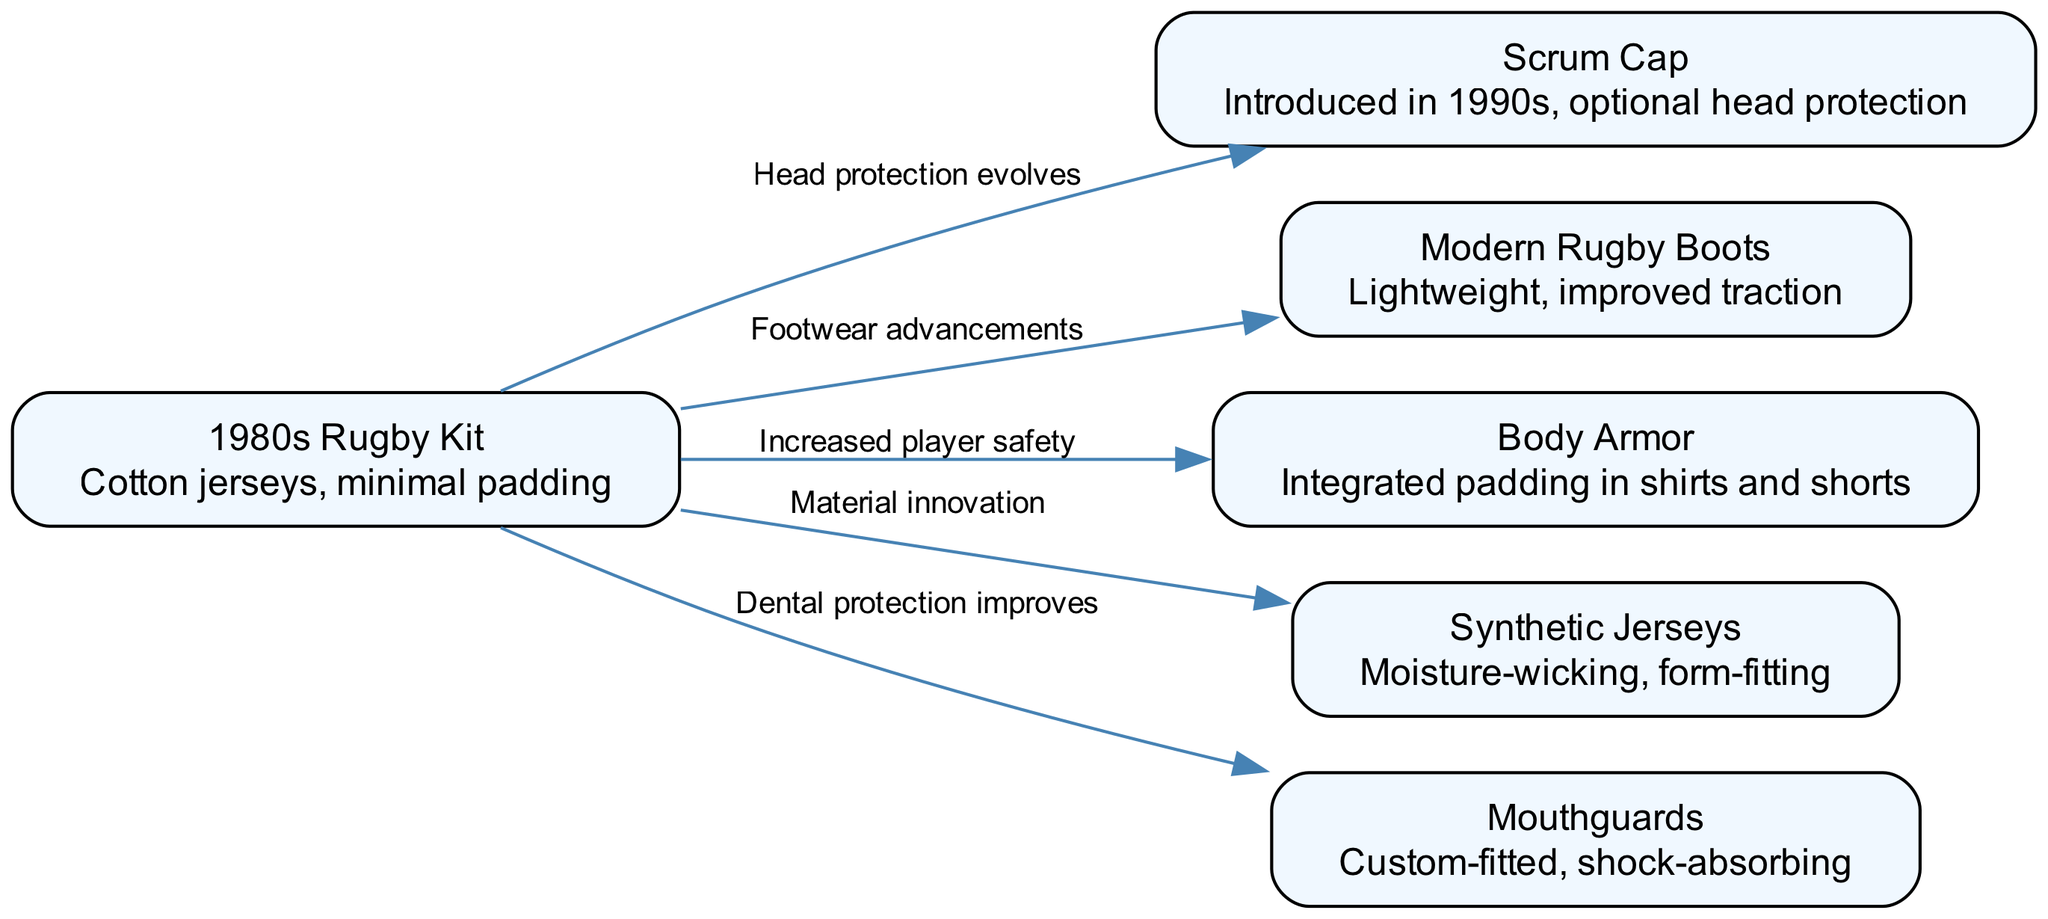What is the name of the rugby kit used in the 1980s? The diagram lists "1980s Rugby Kit" as one of the nodes, indicating the type of kit used during that decade.
Answer: 1980s Rugby Kit What protective gear was introduced in the 1990s? The diagram shows a direct connection from the "1980s Rugby Kit" to "Scrum Cap" with the label "Head protection evolves," indicating that the Scrum Cap was introduced in this era.
Answer: Scrum Cap How many nodes are present in the diagram? The diagram includes six distinct nodes representing different aspects of rugby equipment evolution from the 1980s to the present day. To find the count, we can simply count the nodes listed.
Answer: 6 What type of jersey has moisture-wicking capabilities? The node labeled "Synthetic Jerseys" directly states it has moisture-wicking properties, making it the type of jersey being asked about.
Answer: Synthetic Jerseys Which item is associated with dental protection? Looking at the edges stemming from the initial "1980s Rugby Kit" node, the "Mouthguards" node is linked with the label "Dental protection improves," indicating its association with dental safety.
Answer: Mouthguards How does the diagram show the evolution of player safety? The diagram connects multiple nodes directly to "1980s Rugby Kit," indicating increased player safety over time through innovations like body armor, scrum caps, and mouthguards. The connections reflect that these advancements were introduced to enhance player safety.
Answer: Increased player safety Which rugby equipment advancement improves traction? The edge labeled "Footwear advancements" indicates that the node "Modern Rugby Boots" is specifically designed with improved traction over those from previous decades.
Answer: Modern Rugby Boots What relationship do synthetic jerseys have with earlier rugby kits? The diagram shows a connection from "1980s Rugby Kit" to "Synthetic Jerseys" with the label "Material innovation," indicating that synthetic jerseys emerged as a result of advancements in materials compared to those used in the 1980s.
Answer: Material innovation Which protective gear is described as optional? The diagram specifies that the "Scrum Cap," which evolved as head protection, is noted as an optional piece of equipment rather than a required one.
Answer: Optional head protection 